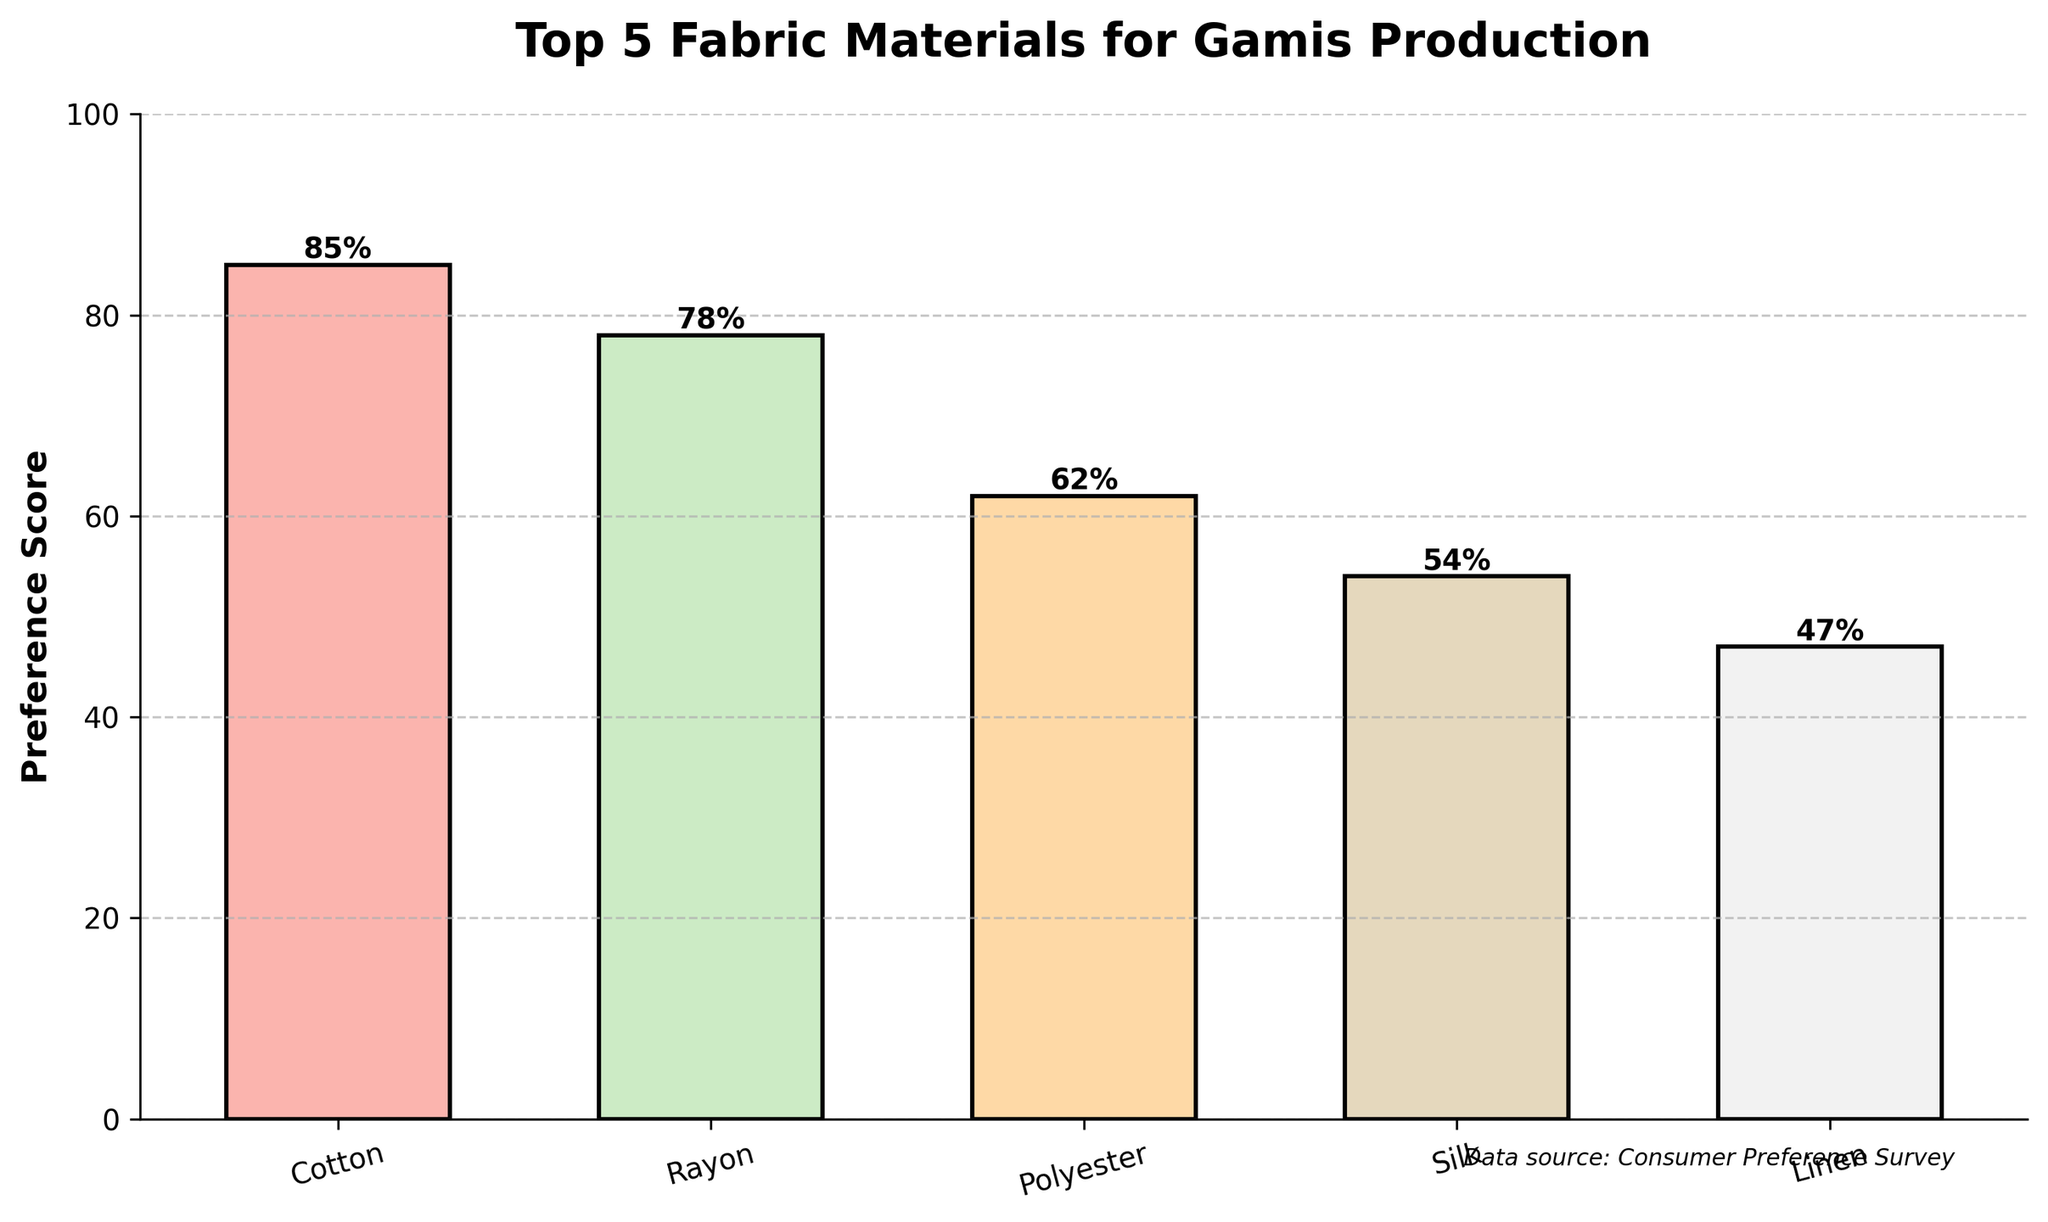what is the most preferred fabric material for gamis production? The bar chart shows the preference scores for five fabric materials. The material with the highest bar is the most preferred. Cotton has the highest preference score of 85.
Answer: Cotton How much more preferred is Cotton compared to Polyester? The preference score for Cotton is 85, and for Polyester, it is 62. Subtract the preference score of Polyester from Cotton: 85 - 62 = 23.
Answer: 23 what is the total preference score of Rayon and Silk combined? The preference score for Rayon is 78, and for Silk, it is 54. Adding these two scores: 78 + 54 = 132.
Answer: 132 Which material has the lowest preference score and what is that score? The bar chart shows that Linen has the lowest bar, indicating it has the lowest preference score of 47.
Answer: Linen, 47 Is Rayon more preferred than Polyester? Comparing the height of the bars for Rayon and Polyester, Rayon has a preference score of 78, while Polyester has a score of 62. Since 78 is greater than 62, Rayon is more preferred than Polyester.
Answer: Yes Which two materials have a combined preference score of over 120? Checking the preference scores: Cotton (85), Rayon (78), Polyester (62), Silk (54), and Linen (47). Adding Cotton and Rayon scores: 85 + 78 = 163. No other combination exceeds 120.
Answer: Cotton and Rayon What is the average preference score of all the materials? The preference scores are Cotton (85), Rayon (78), Polyester (62), Silk (54), and Linen (47). Summing these scores: 85 + 78 + 62 + 54 + 47 = 326. Dividing by the number of materials (5): 326 / 5 = 65.2.
Answer: 65.2 Which color represents Rayon and what is its preference score? The bar for Rayon is second from the left and represented in a pastel color. The preference score for Rayon is 78.
Answer: Pastel, 78 Compare the preference score difference between Silk and Linen. The preference score for Silk is 54, and for Linen, it is 47. Subtract the score of Linen from Silk: 54 - 47 = 7.
Answer: 7 